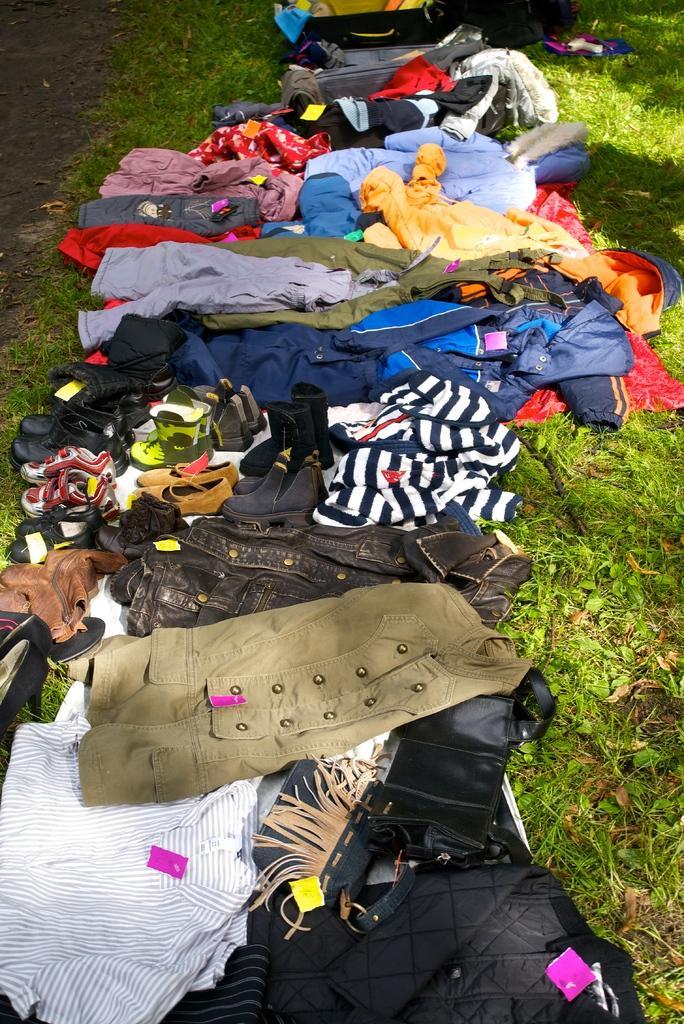In one or two sentences, can you explain what this image depicts? In the picture we can see a grass surface on it we can see many clothes are placed on it with some foot wear. 